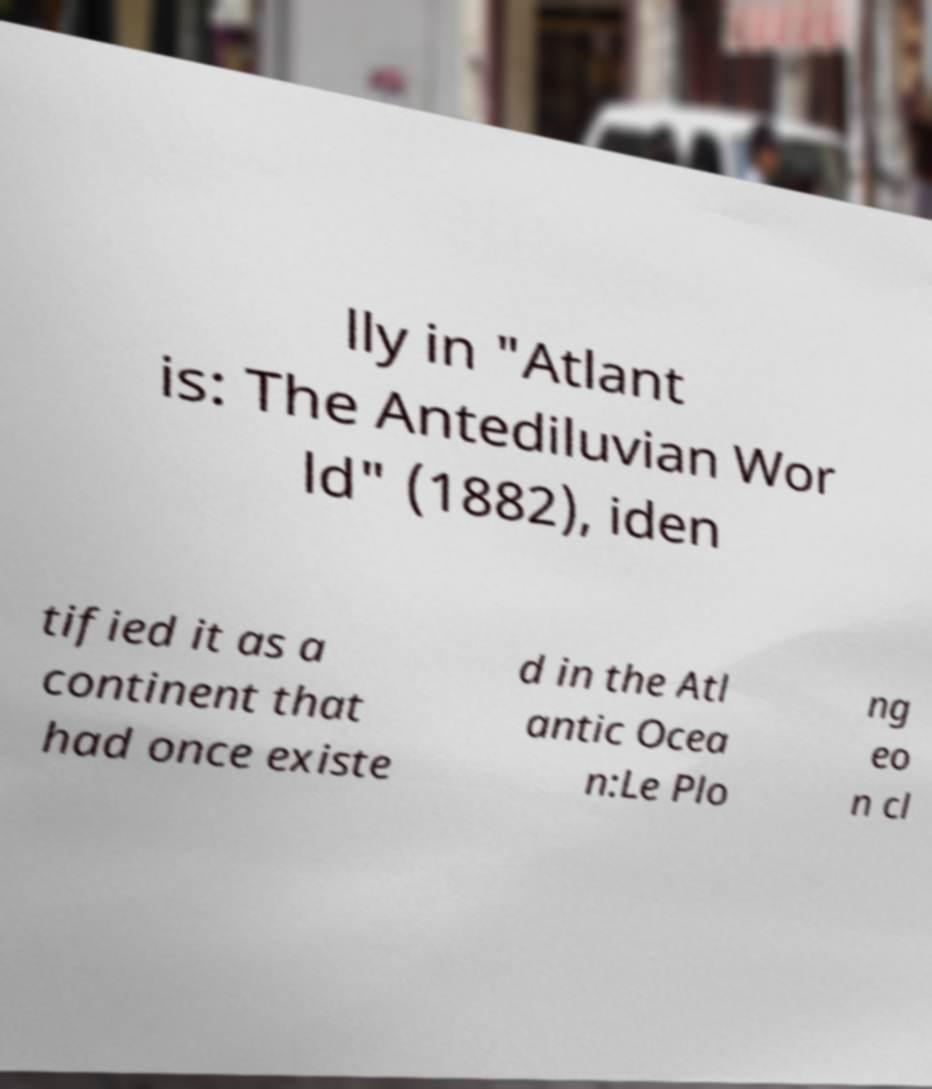There's text embedded in this image that I need extracted. Can you transcribe it verbatim? lly in "Atlant is: The Antediluvian Wor ld" (1882), iden tified it as a continent that had once existe d in the Atl antic Ocea n:Le Plo ng eo n cl 